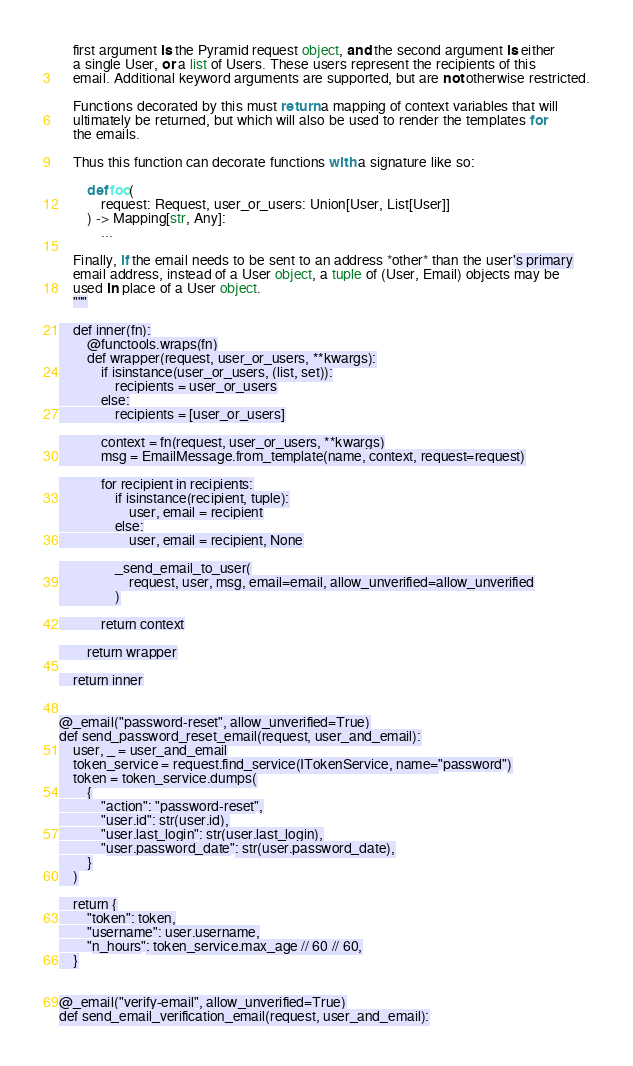Convert code to text. <code><loc_0><loc_0><loc_500><loc_500><_Python_>    first argument is the Pyramid request object, and the second argument is either
    a single User, or a list of Users. These users represent the recipients of this
    email. Additional keyword arguments are supported, but are not otherwise restricted.

    Functions decorated by this must return a mapping of context variables that will
    ultimately be returned, but which will also be used to render the templates for
    the emails.

    Thus this function can decorate functions with a signature like so:

        def foo(
            request: Request, user_or_users: Union[User, List[User]]
        ) -> Mapping[str, Any]:
            ...

    Finally, if the email needs to be sent to an address *other* than the user's primary
    email address, instead of a User object, a tuple of (User, Email) objects may be
    used in place of a User object.
    """

    def inner(fn):
        @functools.wraps(fn)
        def wrapper(request, user_or_users, **kwargs):
            if isinstance(user_or_users, (list, set)):
                recipients = user_or_users
            else:
                recipients = [user_or_users]

            context = fn(request, user_or_users, **kwargs)
            msg = EmailMessage.from_template(name, context, request=request)

            for recipient in recipients:
                if isinstance(recipient, tuple):
                    user, email = recipient
                else:
                    user, email = recipient, None

                _send_email_to_user(
                    request, user, msg, email=email, allow_unverified=allow_unverified
                )

            return context

        return wrapper

    return inner


@_email("password-reset", allow_unverified=True)
def send_password_reset_email(request, user_and_email):
    user, _ = user_and_email
    token_service = request.find_service(ITokenService, name="password")
    token = token_service.dumps(
        {
            "action": "password-reset",
            "user.id": str(user.id),
            "user.last_login": str(user.last_login),
            "user.password_date": str(user.password_date),
        }
    )

    return {
        "token": token,
        "username": user.username,
        "n_hours": token_service.max_age // 60 // 60,
    }


@_email("verify-email", allow_unverified=True)
def send_email_verification_email(request, user_and_email):</code> 